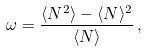Convert formula to latex. <formula><loc_0><loc_0><loc_500><loc_500>\omega = \frac { \langle N ^ { 2 } \rangle - \langle N \rangle ^ { 2 } } { \langle N \rangle } \, ,</formula> 